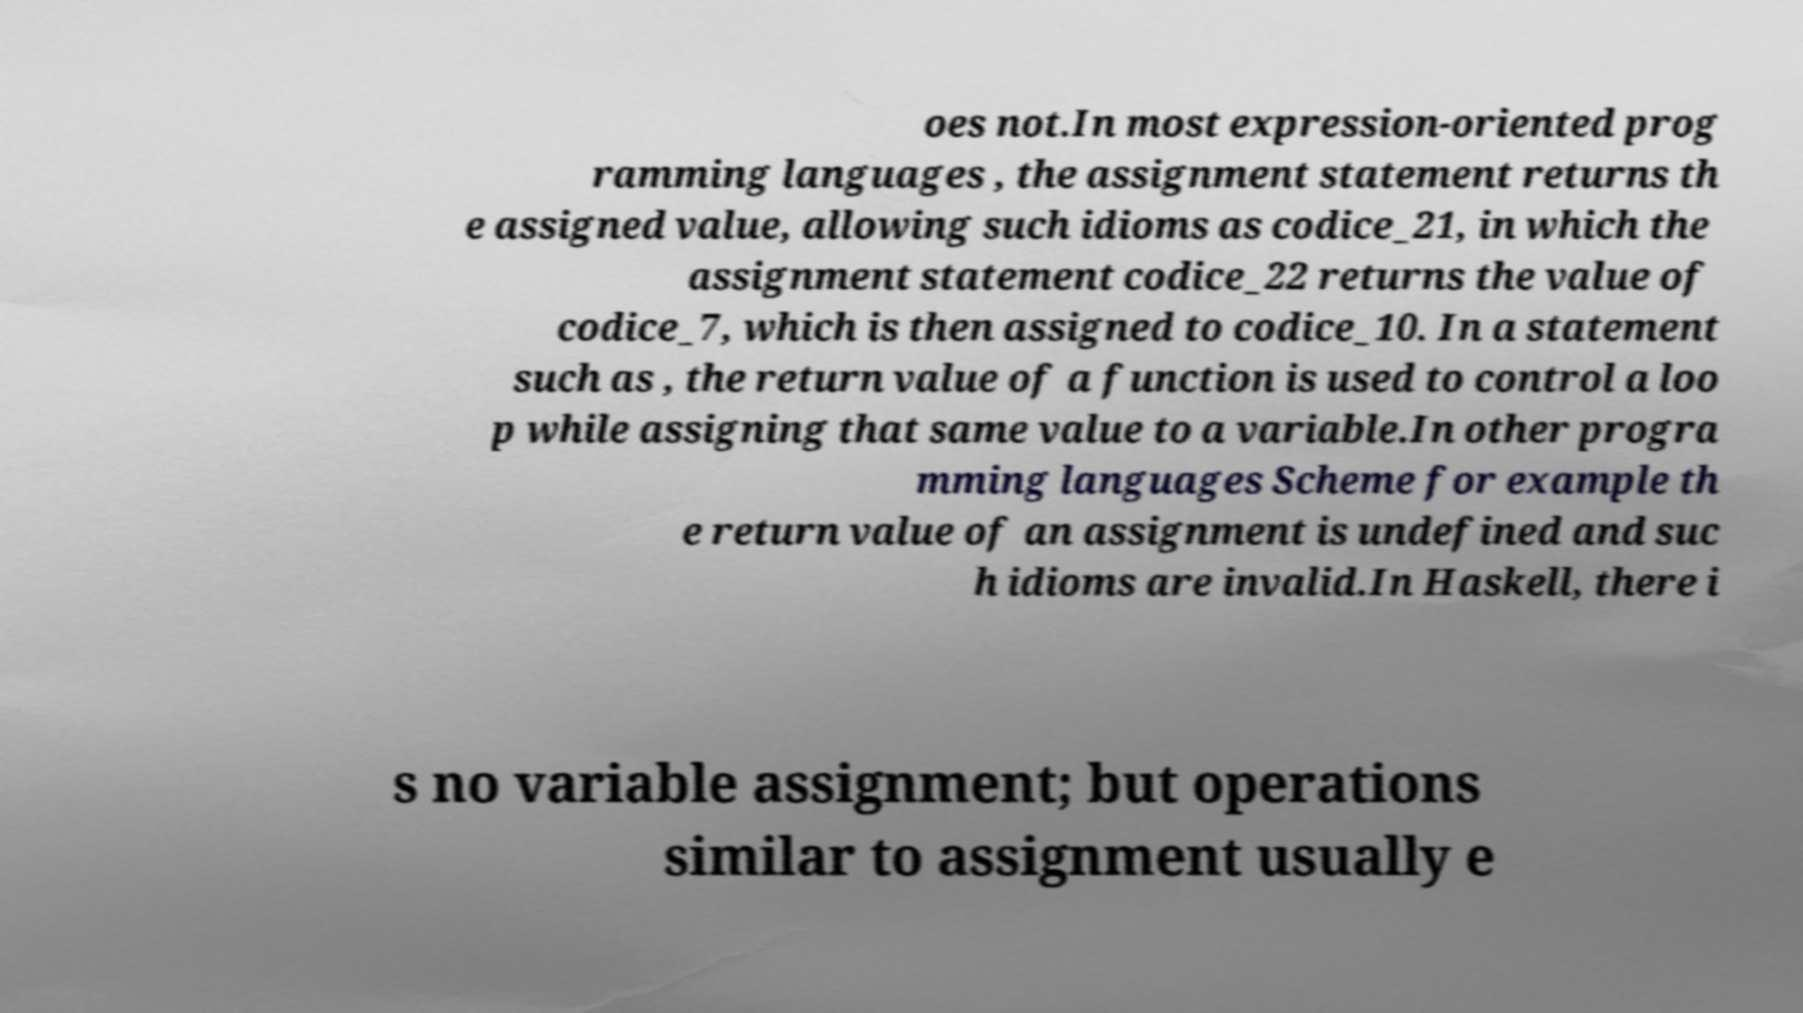I need the written content from this picture converted into text. Can you do that? oes not.In most expression-oriented prog ramming languages , the assignment statement returns th e assigned value, allowing such idioms as codice_21, in which the assignment statement codice_22 returns the value of codice_7, which is then assigned to codice_10. In a statement such as , the return value of a function is used to control a loo p while assigning that same value to a variable.In other progra mming languages Scheme for example th e return value of an assignment is undefined and suc h idioms are invalid.In Haskell, there i s no variable assignment; but operations similar to assignment usually e 